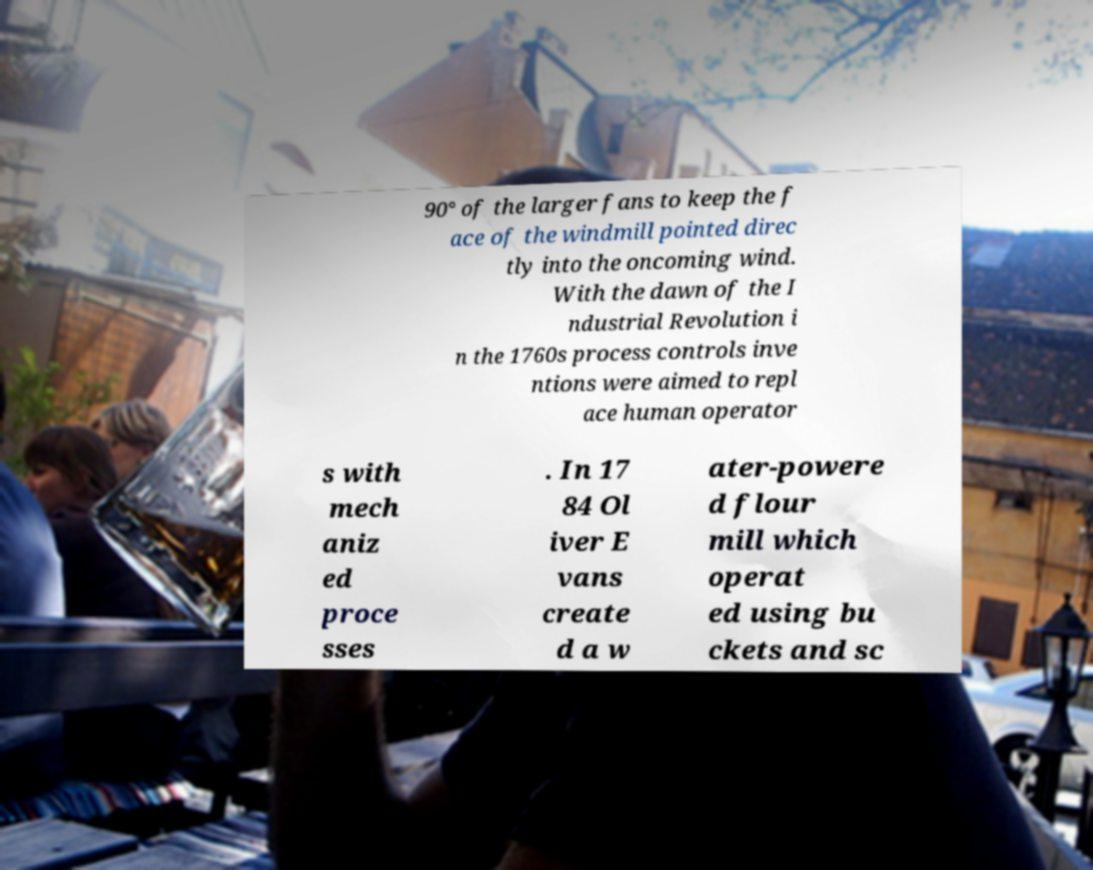Can you accurately transcribe the text from the provided image for me? 90° of the larger fans to keep the f ace of the windmill pointed direc tly into the oncoming wind. With the dawn of the I ndustrial Revolution i n the 1760s process controls inve ntions were aimed to repl ace human operator s with mech aniz ed proce sses . In 17 84 Ol iver E vans create d a w ater-powere d flour mill which operat ed using bu ckets and sc 